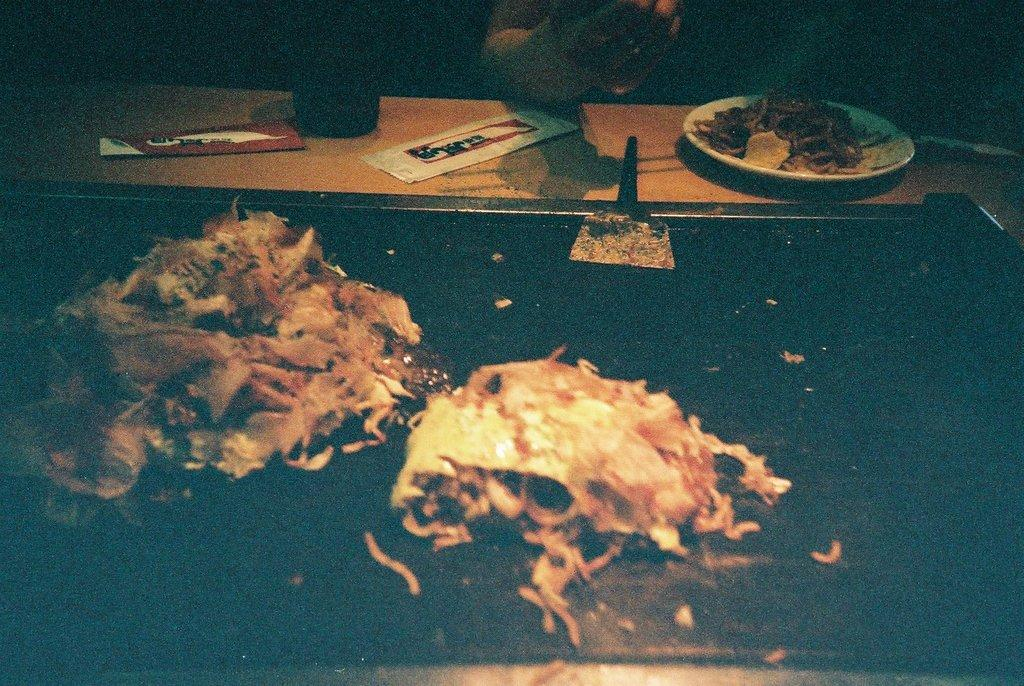What piece of furniture is present in the image? There is a table in the image. What is placed on the table? There is a plate on the table. What is on the plate? There is food on the plate. What utensil is visible in the image? There is a spatula in the image. Whose hand is visible in the image? A person's hand is visible in the image. Can you describe the unspecified objects in the image? Unfortunately, the facts provided do not specify the nature of the unspecified objects in the image. How many frogs are hopping around on the table in the image? There are no frogs present in the image. What type of cemetery can be seen in the background of the image? There is no cemetery present in the image. 